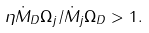<formula> <loc_0><loc_0><loc_500><loc_500>\eta \dot { M } _ { D } \Omega _ { j } / \dot { M } _ { j } \Omega _ { D } > 1 .</formula> 